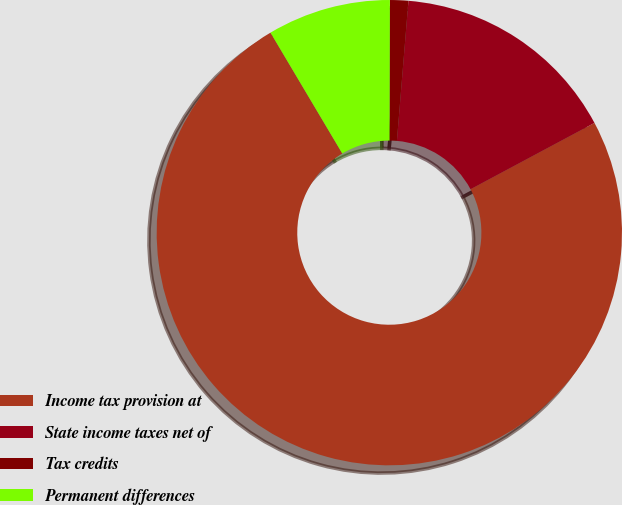<chart> <loc_0><loc_0><loc_500><loc_500><pie_chart><fcel>Income tax provision at<fcel>State income taxes net of<fcel>Tax credits<fcel>Permanent differences<nl><fcel>74.28%<fcel>15.87%<fcel>1.27%<fcel>8.57%<nl></chart> 